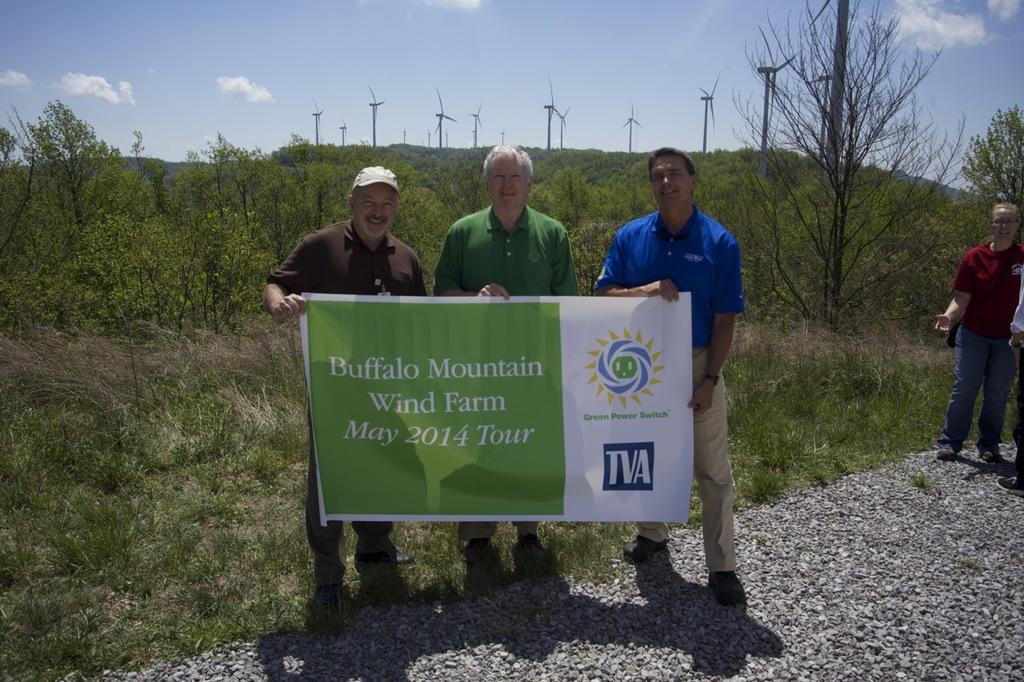Could you give a brief overview of what you see in this image? This is an outside view. Here I can see three men standing, holding a banner in the hands, smiling and giving pose for the picture. On the banner, I can see some text. At the bottom there are stones on the ground. On the right side two persons are standing. In the background there are many plants and trees and also I can see the poles. At the top of the image I can see the sky and clouds. 